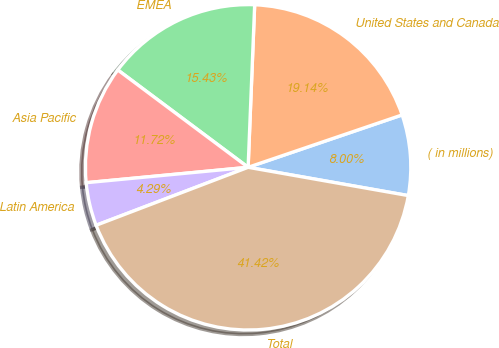<chart> <loc_0><loc_0><loc_500><loc_500><pie_chart><fcel>( in millions)<fcel>United States and Canada<fcel>EMEA<fcel>Asia Pacific<fcel>Latin America<fcel>Total<nl><fcel>8.0%<fcel>19.14%<fcel>15.43%<fcel>11.72%<fcel>4.29%<fcel>41.42%<nl></chart> 